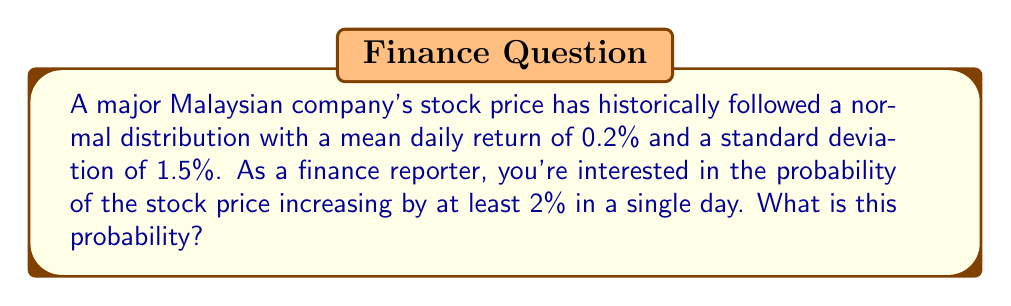Help me with this question. Let's approach this step-by-step:

1) Let X be the daily return of the stock. We're given that X follows a normal distribution with:
   $\mu = 0.2\%$ (mean)
   $\sigma = 1.5\%$ (standard deviation)

2) We want to find P(X ≥ 2%), which is the probability that X is greater than or equal to 2%.

3) To solve this, we need to calculate the z-score for 2%:

   $$z = \frac{x - \mu}{\sigma} = \frac{2 - 0.2}{1.5} = 1.2$$

4) Now, we need to find P(Z ≥ 1.2) where Z is the standard normal distribution.

5) Using a standard normal table or calculator, we can find that:
   P(Z ≥ 1.2) = 1 - P(Z < 1.2) = 1 - 0.8849 = 0.1151

6) Therefore, the probability of the stock price increasing by at least 2% in a single day is approximately 0.1151 or 11.51%.
Answer: 0.1151 or 11.51% 